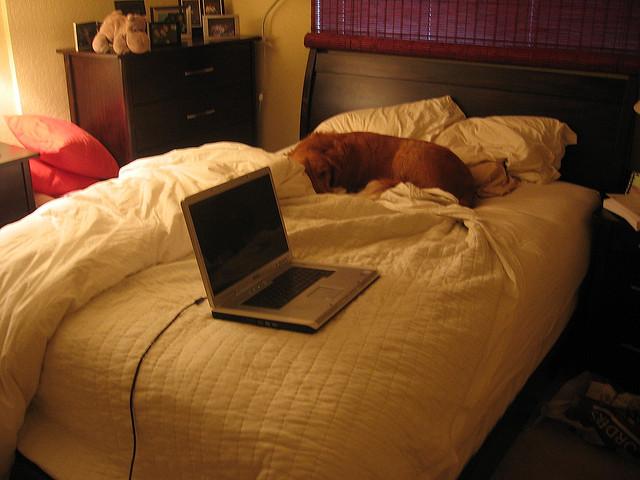What is on the bed?
Keep it brief. Dog and laptop. What print is on the bed sheets?
Be succinct. None. Is the dog sleeping?
Be succinct. Yes. Why would someone put their laptop on the bed?
Write a very short answer. Work. 